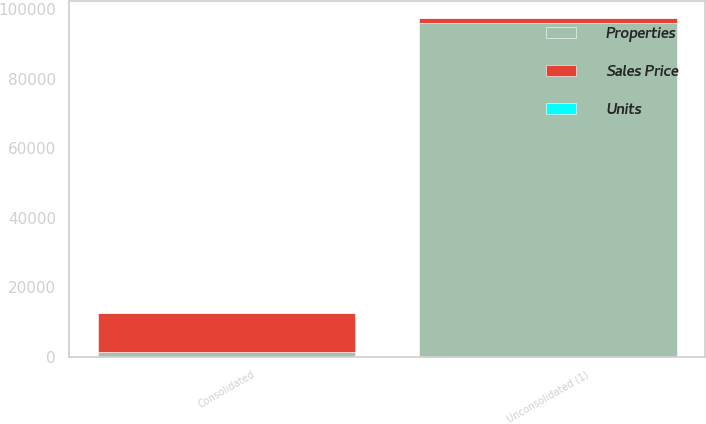Convert chart to OTSL. <chart><loc_0><loc_0><loc_500><loc_500><stacked_bar_chart><ecel><fcel>Consolidated<fcel>Unconsolidated (1)<nl><fcel>Units<fcel>54<fcel>6<nl><fcel>Sales Price<fcel>11055<fcel>1434<nl><fcel>Properties<fcel>1434<fcel>96018<nl></chart> 